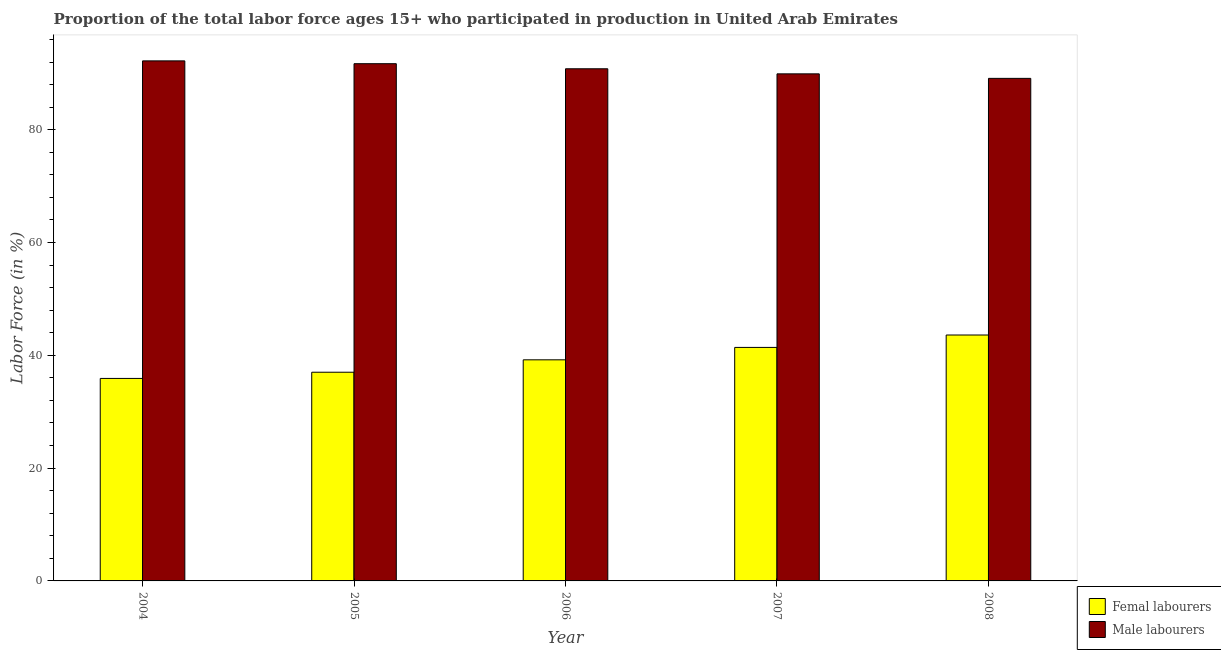How many different coloured bars are there?
Keep it short and to the point. 2. How many groups of bars are there?
Ensure brevity in your answer.  5. Are the number of bars on each tick of the X-axis equal?
Make the answer very short. Yes. What is the percentage of female labor force in 2008?
Your response must be concise. 43.6. Across all years, what is the maximum percentage of female labor force?
Offer a very short reply. 43.6. Across all years, what is the minimum percentage of female labor force?
Your answer should be very brief. 35.9. In which year was the percentage of male labour force maximum?
Offer a very short reply. 2004. What is the total percentage of male labour force in the graph?
Keep it short and to the point. 453.7. What is the difference between the percentage of male labour force in 2006 and that in 2008?
Offer a very short reply. 1.7. What is the difference between the percentage of female labor force in 2005 and the percentage of male labour force in 2007?
Your answer should be compact. -4.4. What is the average percentage of female labor force per year?
Your answer should be compact. 39.42. In how many years, is the percentage of male labour force greater than 48 %?
Your response must be concise. 5. What is the ratio of the percentage of female labor force in 2004 to that in 2006?
Ensure brevity in your answer.  0.92. Is the percentage of female labor force in 2004 less than that in 2006?
Your response must be concise. Yes. What is the difference between the highest and the second highest percentage of female labor force?
Your answer should be compact. 2.2. What is the difference between the highest and the lowest percentage of female labor force?
Make the answer very short. 7.7. What does the 2nd bar from the left in 2006 represents?
Ensure brevity in your answer.  Male labourers. What does the 1st bar from the right in 2005 represents?
Offer a very short reply. Male labourers. How many bars are there?
Your answer should be very brief. 10. What is the difference between two consecutive major ticks on the Y-axis?
Make the answer very short. 20. Does the graph contain grids?
Make the answer very short. No. Where does the legend appear in the graph?
Your answer should be very brief. Bottom right. How are the legend labels stacked?
Your response must be concise. Vertical. What is the title of the graph?
Keep it short and to the point. Proportion of the total labor force ages 15+ who participated in production in United Arab Emirates. Does "Revenue" appear as one of the legend labels in the graph?
Offer a very short reply. No. What is the label or title of the X-axis?
Your response must be concise. Year. What is the Labor Force (in %) of Femal labourers in 2004?
Offer a terse response. 35.9. What is the Labor Force (in %) in Male labourers in 2004?
Your response must be concise. 92.2. What is the Labor Force (in %) in Male labourers in 2005?
Your answer should be very brief. 91.7. What is the Labor Force (in %) of Femal labourers in 2006?
Offer a terse response. 39.2. What is the Labor Force (in %) in Male labourers in 2006?
Provide a short and direct response. 90.8. What is the Labor Force (in %) in Femal labourers in 2007?
Keep it short and to the point. 41.4. What is the Labor Force (in %) of Male labourers in 2007?
Ensure brevity in your answer.  89.9. What is the Labor Force (in %) of Femal labourers in 2008?
Give a very brief answer. 43.6. What is the Labor Force (in %) in Male labourers in 2008?
Offer a very short reply. 89.1. Across all years, what is the maximum Labor Force (in %) of Femal labourers?
Give a very brief answer. 43.6. Across all years, what is the maximum Labor Force (in %) in Male labourers?
Keep it short and to the point. 92.2. Across all years, what is the minimum Labor Force (in %) in Femal labourers?
Make the answer very short. 35.9. Across all years, what is the minimum Labor Force (in %) in Male labourers?
Ensure brevity in your answer.  89.1. What is the total Labor Force (in %) in Femal labourers in the graph?
Your response must be concise. 197.1. What is the total Labor Force (in %) of Male labourers in the graph?
Give a very brief answer. 453.7. What is the difference between the Labor Force (in %) in Femal labourers in 2004 and that in 2005?
Offer a very short reply. -1.1. What is the difference between the Labor Force (in %) in Male labourers in 2004 and that in 2005?
Offer a terse response. 0.5. What is the difference between the Labor Force (in %) in Femal labourers in 2004 and that in 2008?
Make the answer very short. -7.7. What is the difference between the Labor Force (in %) of Femal labourers in 2005 and that in 2007?
Your answer should be very brief. -4.4. What is the difference between the Labor Force (in %) of Male labourers in 2005 and that in 2007?
Provide a succinct answer. 1.8. What is the difference between the Labor Force (in %) of Femal labourers in 2005 and that in 2008?
Your answer should be compact. -6.6. What is the difference between the Labor Force (in %) in Male labourers in 2005 and that in 2008?
Make the answer very short. 2.6. What is the difference between the Labor Force (in %) of Femal labourers in 2006 and that in 2007?
Provide a succinct answer. -2.2. What is the difference between the Labor Force (in %) in Male labourers in 2006 and that in 2007?
Give a very brief answer. 0.9. What is the difference between the Labor Force (in %) in Femal labourers in 2006 and that in 2008?
Your answer should be very brief. -4.4. What is the difference between the Labor Force (in %) of Femal labourers in 2004 and the Labor Force (in %) of Male labourers in 2005?
Your answer should be compact. -55.8. What is the difference between the Labor Force (in %) in Femal labourers in 2004 and the Labor Force (in %) in Male labourers in 2006?
Keep it short and to the point. -54.9. What is the difference between the Labor Force (in %) in Femal labourers in 2004 and the Labor Force (in %) in Male labourers in 2007?
Offer a terse response. -54. What is the difference between the Labor Force (in %) of Femal labourers in 2004 and the Labor Force (in %) of Male labourers in 2008?
Make the answer very short. -53.2. What is the difference between the Labor Force (in %) of Femal labourers in 2005 and the Labor Force (in %) of Male labourers in 2006?
Give a very brief answer. -53.8. What is the difference between the Labor Force (in %) of Femal labourers in 2005 and the Labor Force (in %) of Male labourers in 2007?
Provide a short and direct response. -52.9. What is the difference between the Labor Force (in %) in Femal labourers in 2005 and the Labor Force (in %) in Male labourers in 2008?
Provide a short and direct response. -52.1. What is the difference between the Labor Force (in %) of Femal labourers in 2006 and the Labor Force (in %) of Male labourers in 2007?
Keep it short and to the point. -50.7. What is the difference between the Labor Force (in %) in Femal labourers in 2006 and the Labor Force (in %) in Male labourers in 2008?
Your answer should be very brief. -49.9. What is the difference between the Labor Force (in %) in Femal labourers in 2007 and the Labor Force (in %) in Male labourers in 2008?
Offer a terse response. -47.7. What is the average Labor Force (in %) of Femal labourers per year?
Provide a succinct answer. 39.42. What is the average Labor Force (in %) of Male labourers per year?
Ensure brevity in your answer.  90.74. In the year 2004, what is the difference between the Labor Force (in %) of Femal labourers and Labor Force (in %) of Male labourers?
Provide a short and direct response. -56.3. In the year 2005, what is the difference between the Labor Force (in %) of Femal labourers and Labor Force (in %) of Male labourers?
Offer a very short reply. -54.7. In the year 2006, what is the difference between the Labor Force (in %) of Femal labourers and Labor Force (in %) of Male labourers?
Your answer should be very brief. -51.6. In the year 2007, what is the difference between the Labor Force (in %) of Femal labourers and Labor Force (in %) of Male labourers?
Offer a terse response. -48.5. In the year 2008, what is the difference between the Labor Force (in %) of Femal labourers and Labor Force (in %) of Male labourers?
Provide a succinct answer. -45.5. What is the ratio of the Labor Force (in %) of Femal labourers in 2004 to that in 2005?
Keep it short and to the point. 0.97. What is the ratio of the Labor Force (in %) of Femal labourers in 2004 to that in 2006?
Your answer should be very brief. 0.92. What is the ratio of the Labor Force (in %) of Male labourers in 2004 to that in 2006?
Offer a very short reply. 1.02. What is the ratio of the Labor Force (in %) in Femal labourers in 2004 to that in 2007?
Your answer should be compact. 0.87. What is the ratio of the Labor Force (in %) in Male labourers in 2004 to that in 2007?
Provide a succinct answer. 1.03. What is the ratio of the Labor Force (in %) of Femal labourers in 2004 to that in 2008?
Provide a succinct answer. 0.82. What is the ratio of the Labor Force (in %) of Male labourers in 2004 to that in 2008?
Keep it short and to the point. 1.03. What is the ratio of the Labor Force (in %) in Femal labourers in 2005 to that in 2006?
Offer a terse response. 0.94. What is the ratio of the Labor Force (in %) in Male labourers in 2005 to that in 2006?
Your answer should be compact. 1.01. What is the ratio of the Labor Force (in %) in Femal labourers in 2005 to that in 2007?
Provide a short and direct response. 0.89. What is the ratio of the Labor Force (in %) in Femal labourers in 2005 to that in 2008?
Your response must be concise. 0.85. What is the ratio of the Labor Force (in %) in Male labourers in 2005 to that in 2008?
Offer a very short reply. 1.03. What is the ratio of the Labor Force (in %) of Femal labourers in 2006 to that in 2007?
Provide a succinct answer. 0.95. What is the ratio of the Labor Force (in %) in Femal labourers in 2006 to that in 2008?
Ensure brevity in your answer.  0.9. What is the ratio of the Labor Force (in %) in Male labourers in 2006 to that in 2008?
Offer a very short reply. 1.02. What is the ratio of the Labor Force (in %) in Femal labourers in 2007 to that in 2008?
Provide a succinct answer. 0.95. What is the difference between the highest and the second highest Labor Force (in %) in Male labourers?
Offer a terse response. 0.5. What is the difference between the highest and the lowest Labor Force (in %) of Femal labourers?
Provide a short and direct response. 7.7. 